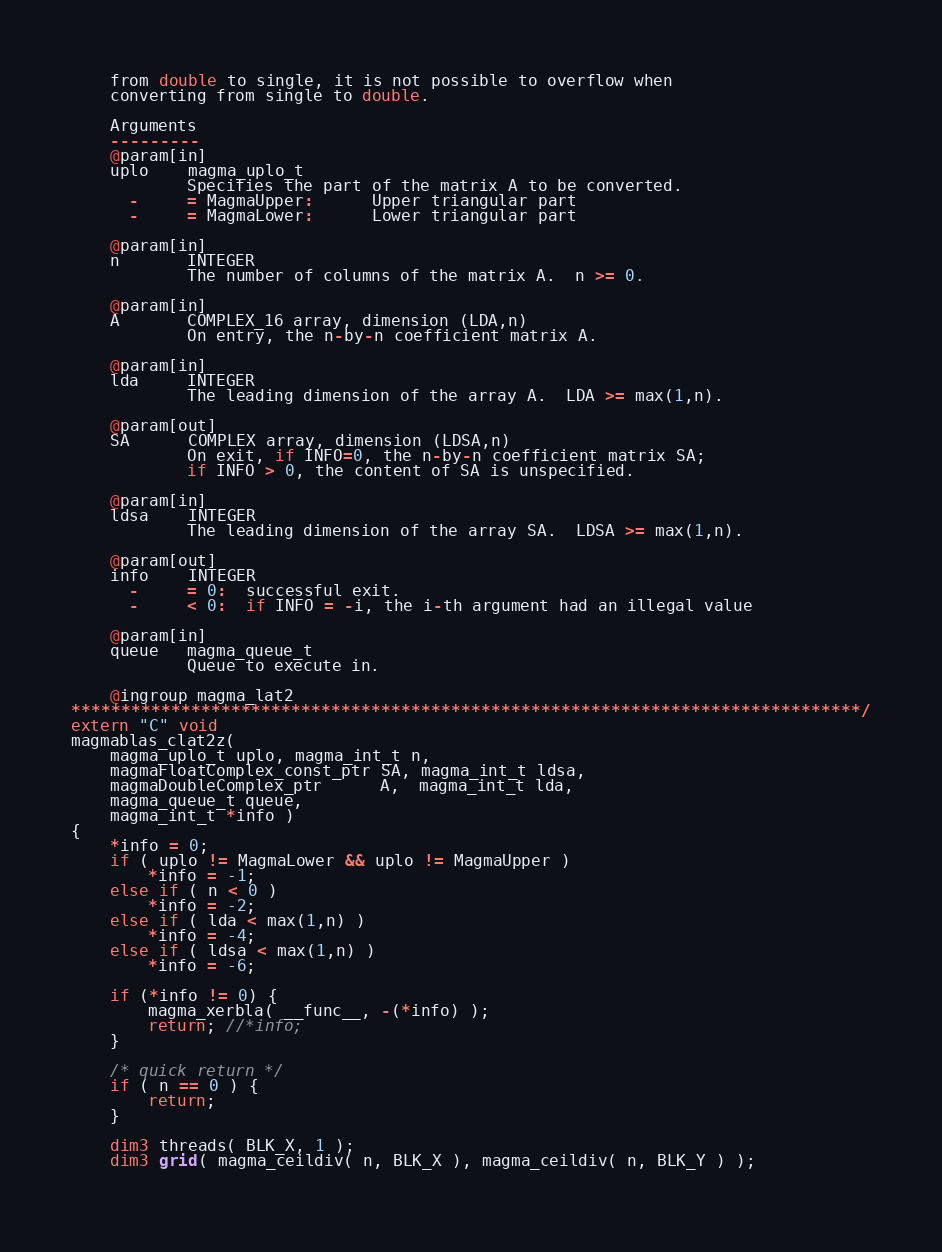<code> <loc_0><loc_0><loc_500><loc_500><_Cuda_>    from double to single, it is not possible to overflow when
    converting from single to double.

    Arguments
    ---------
    @param[in]
    uplo    magma_uplo_t
            Specifies the part of the matrix A to be converted.
      -     = MagmaUpper:      Upper triangular part
      -     = MagmaLower:      Lower triangular part
    
    @param[in]
    n       INTEGER
            The number of columns of the matrix A.  n >= 0.
    
    @param[in]
    A       COMPLEX_16 array, dimension (LDA,n)
            On entry, the n-by-n coefficient matrix A.
    
    @param[in]
    lda     INTEGER
            The leading dimension of the array A.  LDA >= max(1,n).
    
    @param[out]
    SA      COMPLEX array, dimension (LDSA,n)
            On exit, if INFO=0, the n-by-n coefficient matrix SA;
            if INFO > 0, the content of SA is unspecified.
    
    @param[in]
    ldsa    INTEGER
            The leading dimension of the array SA.  LDSA >= max(1,n).
    
    @param[out]
    info    INTEGER
      -     = 0:  successful exit.
      -     < 0:  if INFO = -i, the i-th argument had an illegal value
    
    @param[in]
    queue   magma_queue_t
            Queue to execute in.
    
    @ingroup magma_lat2
*******************************************************************************/
extern "C" void
magmablas_clat2z(
    magma_uplo_t uplo, magma_int_t n,
    magmaFloatComplex_const_ptr SA, magma_int_t ldsa,
    magmaDoubleComplex_ptr      A,  magma_int_t lda,
    magma_queue_t queue,
    magma_int_t *info )
{
    *info = 0;
    if ( uplo != MagmaLower && uplo != MagmaUpper )
        *info = -1;
    else if ( n < 0 )
        *info = -2;
    else if ( lda < max(1,n) )
        *info = -4;
    else if ( ldsa < max(1,n) )
        *info = -6;
    
    if (*info != 0) {
        magma_xerbla( __func__, -(*info) );
        return; //*info;
    }

    /* quick return */
    if ( n == 0 ) {
        return;
    }
    
    dim3 threads( BLK_X, 1 );
    dim3 grid( magma_ceildiv( n, BLK_X ), magma_ceildiv( n, BLK_Y ) );
    </code> 